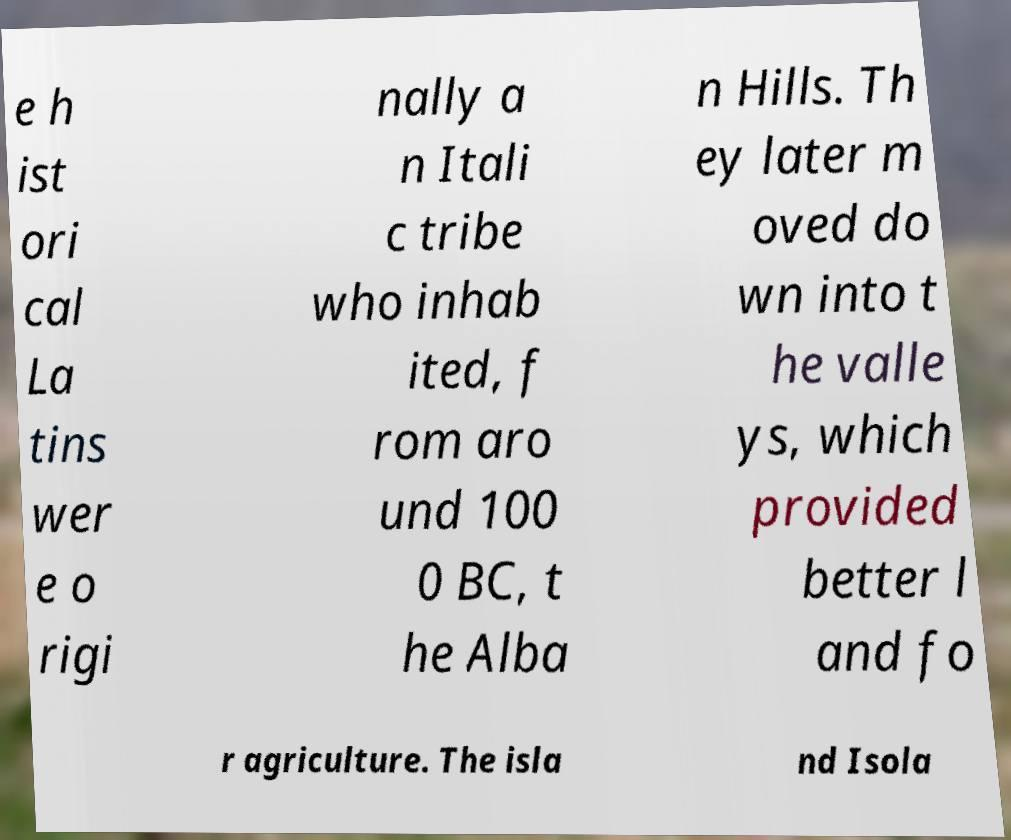Please read and relay the text visible in this image. What does it say? e h ist ori cal La tins wer e o rigi nally a n Itali c tribe who inhab ited, f rom aro und 100 0 BC, t he Alba n Hills. Th ey later m oved do wn into t he valle ys, which provided better l and fo r agriculture. The isla nd Isola 